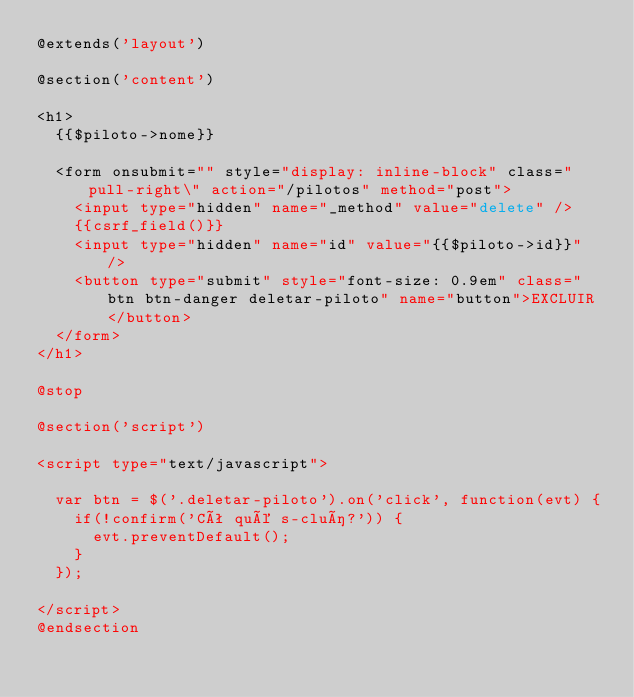<code> <loc_0><loc_0><loc_500><loc_500><_PHP_>@extends('layout')

@section('content')

<h1>
	{{$piloto->nome}}

	<form onsubmit="" style="display: inline-block" class="pull-right\" action="/pilotos" method="post">
		<input type="hidden" name="_method" value="delete" />
		{{csrf_field()}}
		<input type="hidden" name="id" value="{{$piloto->id}}" />
		<button type="submit" style="font-size: 0.9em" class="btn btn-danger deletar-piloto" name="button">EXCLUIR</button>
	</form>
</h1>

@stop

@section('script')

<script type="text/javascript">

  var btn = $('.deletar-piloto').on('click', function(evt) {
    if(!confirm('Cê qué s-cluí?')) {
      evt.preventDefault();
    }
  });

</script>
@endsection</code> 